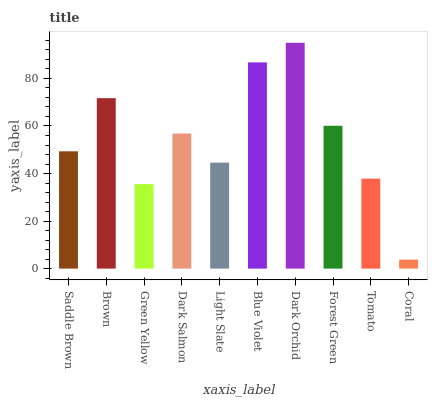Is Brown the minimum?
Answer yes or no. No. Is Brown the maximum?
Answer yes or no. No. Is Brown greater than Saddle Brown?
Answer yes or no. Yes. Is Saddle Brown less than Brown?
Answer yes or no. Yes. Is Saddle Brown greater than Brown?
Answer yes or no. No. Is Brown less than Saddle Brown?
Answer yes or no. No. Is Dark Salmon the high median?
Answer yes or no. Yes. Is Saddle Brown the low median?
Answer yes or no. Yes. Is Brown the high median?
Answer yes or no. No. Is Coral the low median?
Answer yes or no. No. 